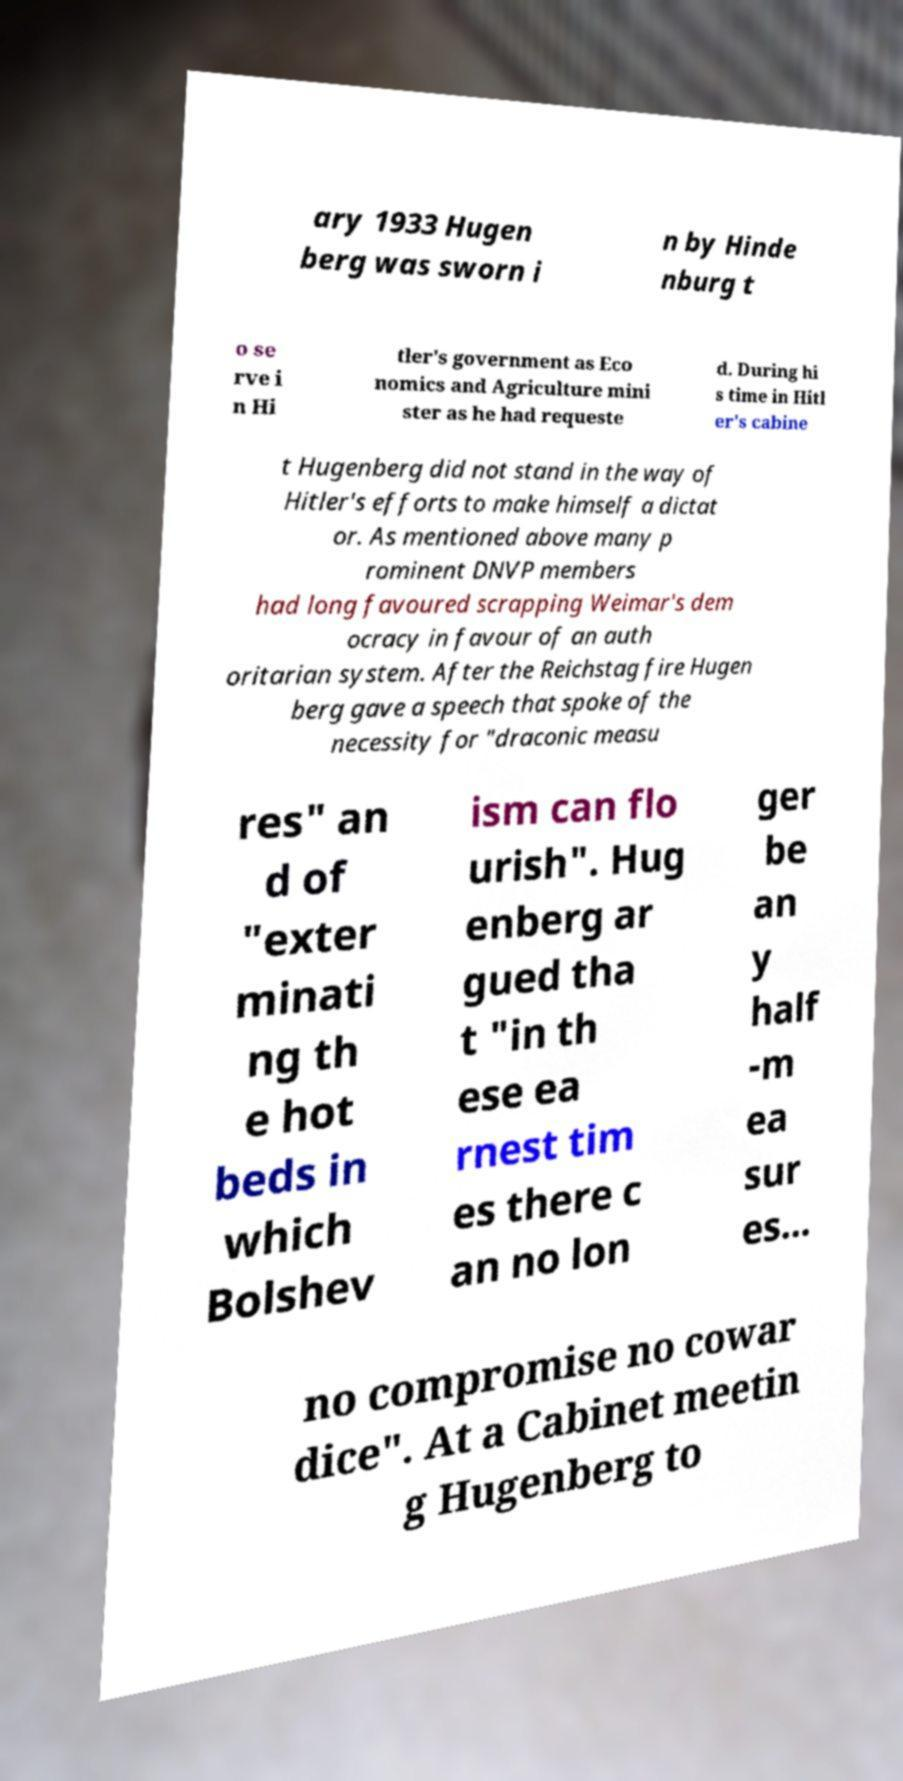There's text embedded in this image that I need extracted. Can you transcribe it verbatim? ary 1933 Hugen berg was sworn i n by Hinde nburg t o se rve i n Hi tler's government as Eco nomics and Agriculture mini ster as he had requeste d. During hi s time in Hitl er's cabine t Hugenberg did not stand in the way of Hitler's efforts to make himself a dictat or. As mentioned above many p rominent DNVP members had long favoured scrapping Weimar's dem ocracy in favour of an auth oritarian system. After the Reichstag fire Hugen berg gave a speech that spoke of the necessity for "draconic measu res" an d of "exter minati ng th e hot beds in which Bolshev ism can flo urish". Hug enberg ar gued tha t "in th ese ea rnest tim es there c an no lon ger be an y half -m ea sur es... no compromise no cowar dice". At a Cabinet meetin g Hugenberg to 